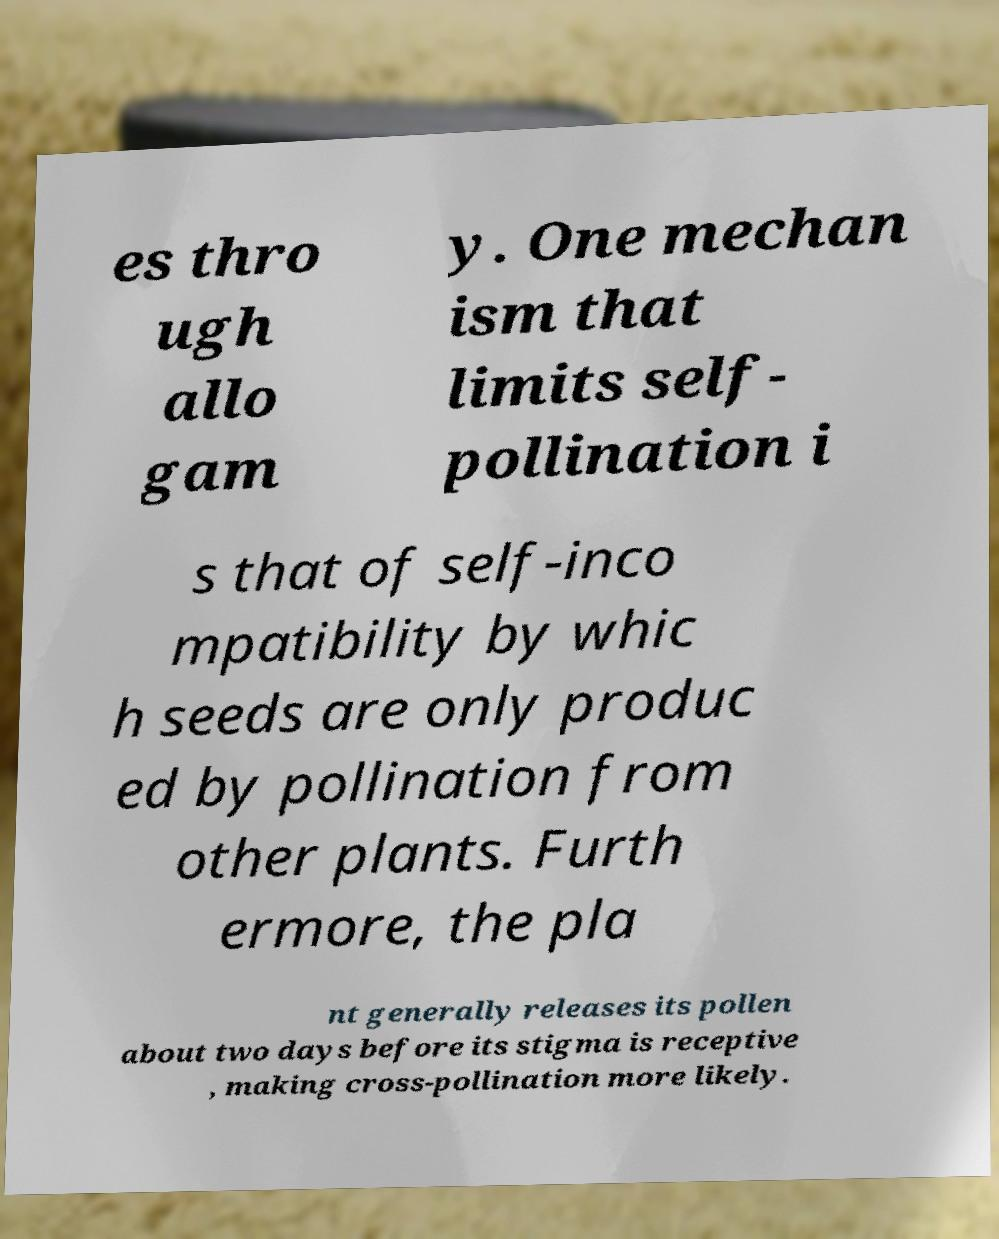There's text embedded in this image that I need extracted. Can you transcribe it verbatim? es thro ugh allo gam y. One mechan ism that limits self- pollination i s that of self-inco mpatibility by whic h seeds are only produc ed by pollination from other plants. Furth ermore, the pla nt generally releases its pollen about two days before its stigma is receptive , making cross-pollination more likely. 